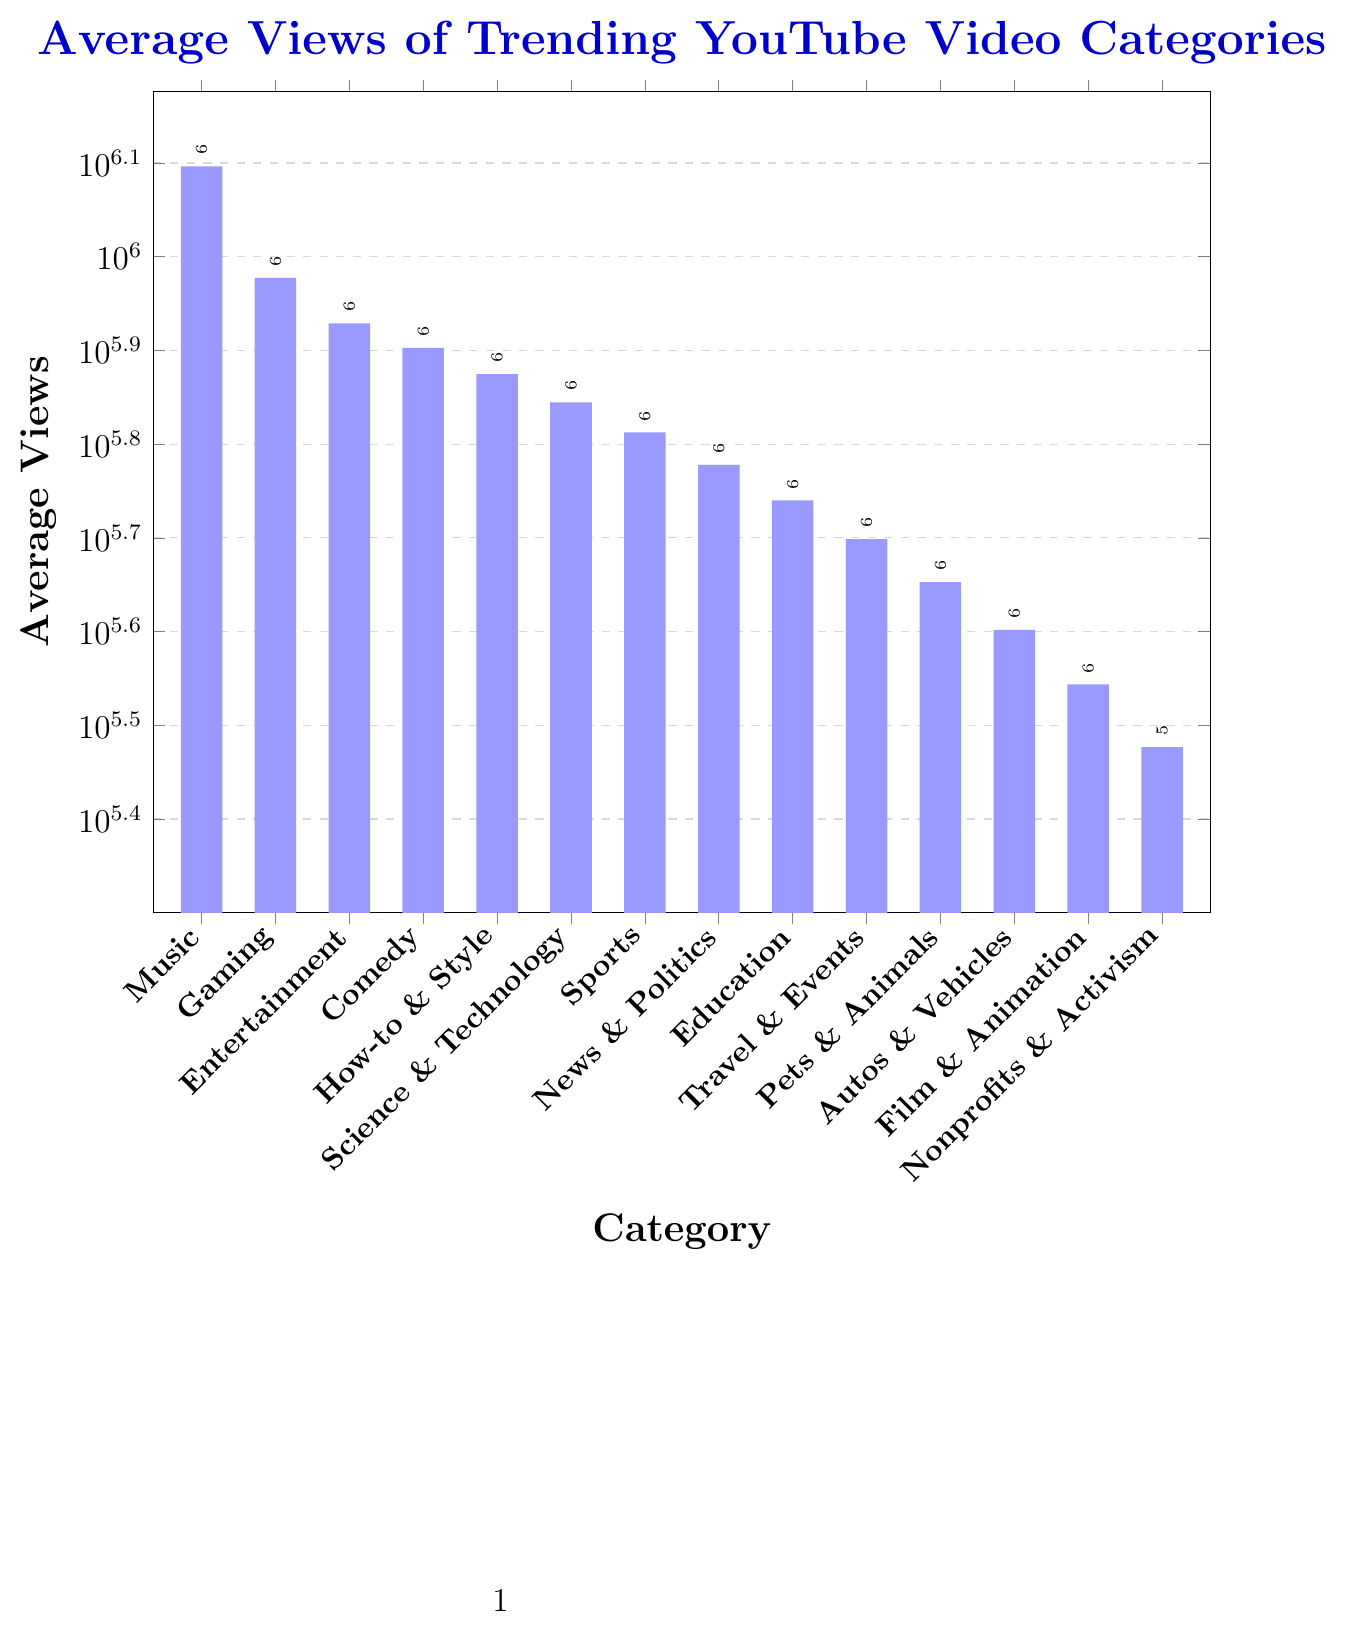What's the category with the highest average views? The category with the highest average views is the one with the tallest bar in the chart. Visually inspect the height of each bar to find the tallest one. The tallest bar corresponds to the 'Music' category.
Answer: Music Which category has more average views: Comedy or How-to & Style? Look at the height of the bars for both the 'Comedy' and 'How-to & Style' categories. The 'Comedy' bar is taller than the 'How-to & Style' bar. Therefore, 'Comedy' has more average views.
Answer: Comedy What's the difference in average views between Music and Entertainment categories? Find the height of the bars for both 'Music' (1,250,000) and 'Entertainment' (850,000). Subtract the average views of 'Entertainment' from 'Music': 1,250,000 - 850,000 = 400,000.
Answer: 400,000 What are the categories with average views less than Science & Technology? Identify the height of the 'Science & Technology' bar (700,000). Any bar shorter than this represents a category with fewer average views. The shorter bars are 'Sports', 'News & Politics', 'Education', 'Travel & Events', 'Pets & Animals', 'Autos & Vehicles', 'Film & Animation', and 'Nonprofits & Activism'.
Answer: Sports, News & Politics, Education, Travel & Events, Pets & Animals, Autos & Vehicles, Film & Animation, Nonprofits & Activism By how much do the average views of Gaming differ from that of Sports? Observe the height of the 'Gaming' bar (950,000) and the 'Sports' bar (650,000). Subtract the average views of 'Sports' from 'Gaming': 950,000 - 650,000 = 300,000.
Answer: 300,000 What is the average view count for the top three categories combined? Identify the height of the bars for the top three categories, which are 'Music', 'Gaming', and 'Entertainment'. Add their values: 1,250,000 (Music) + 950,000 (Gaming) + 850,000 (Entertainment) = 3,050,000.
Answer: 3,050,000 Which category has the closest average views to 'Pets & Animals'? Find the height of the 'Pets & Animals' bar (450,000) and compare it with the heights of the other categories' bars. 'Autos & Vehicles' has the next closest value with 400,000 average views.
Answer: Autos & Vehicles How many categories have average views above 500,000? Count the number of bars with heights greater than 500,000. These bars correspond to categories with more than 500,000 average views. The categories are 'Music', 'Gaming', 'Entertainment', 'Comedy', 'How-to & Style', 'Science & Technology', 'Sports', and 'News & Politics', making a total of 8 categories.
Answer: 8 What is the ratio of average views between Film & Animation and Nonprofits & Activism? Note the height of the 'Film & Animation' bar (350,000) and the 'Nonprofits & Activism' bar (300,000). Divide the average views of 'Film & Animation' by that of 'Nonprofits & Activism': 350,000 / 300,000 = 7/6 or approximately 1.17.
Answer: 1.17 What's the sum of the average views for the categories 'Travel & Events' and 'Education'? Look at the height of the bars for 'Travel & Events' (500,000) and 'Education' (550,000). Add their values: 500,000 + 550,000 = 1,050,000.
Answer: 1,050,000 